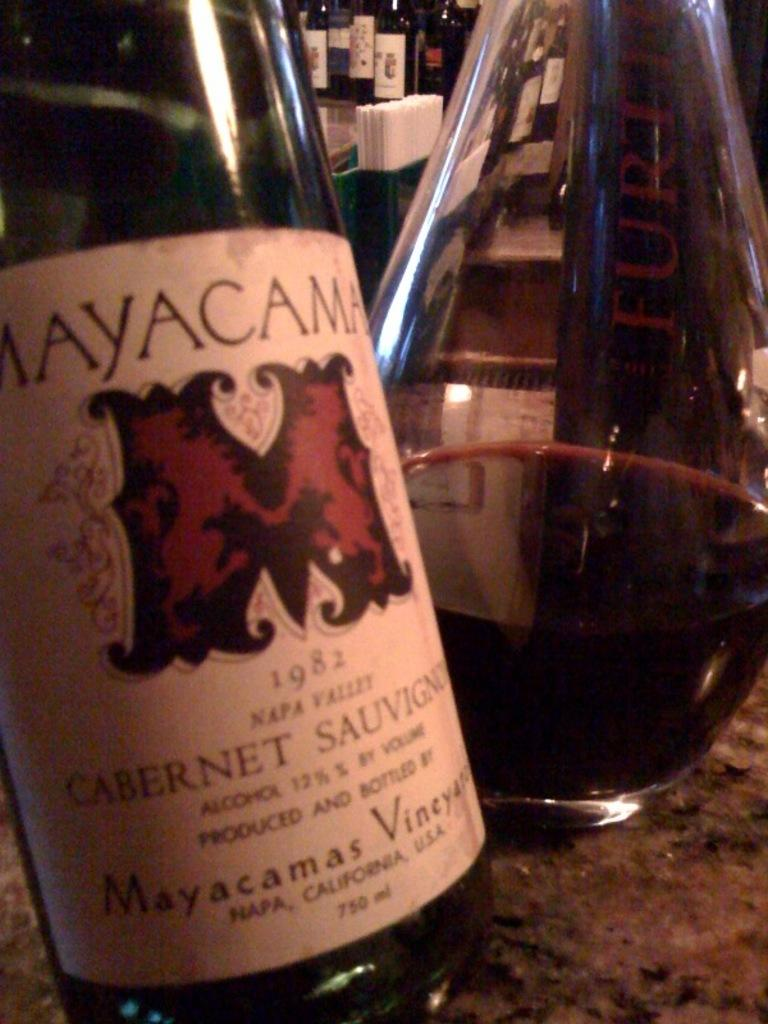<image>
Render a clear and concise summary of the photo. Mayacama Cabernet Sauvignon 1982 wine bottle in front of a glass bottle on a bar 